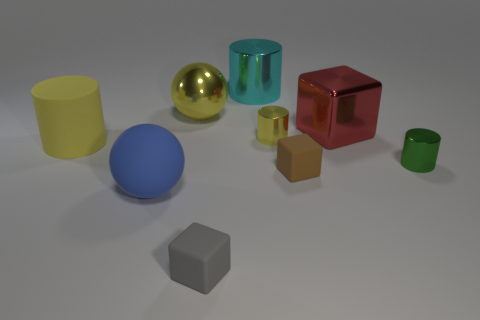What is the material of the large object that is the same color as the shiny ball?
Give a very brief answer. Rubber. Is the color of the rubber ball the same as the metallic sphere?
Keep it short and to the point. No. Is the color of the tiny shiny cylinder right of the small yellow object the same as the cylinder that is behind the red thing?
Offer a terse response. No. There is a block that is behind the small matte block behind the gray rubber block that is on the right side of the big rubber cylinder; how big is it?
Your answer should be very brief. Large. There is another rubber object that is the same shape as the gray rubber thing; what color is it?
Provide a succinct answer. Brown. Is the number of large balls that are to the right of the brown rubber thing greater than the number of tiny green metallic cylinders?
Your response must be concise. No. Do the small gray object and the large yellow object that is in front of the big yellow metallic object have the same shape?
Provide a succinct answer. No. Are there any other things that have the same size as the blue thing?
Provide a succinct answer. Yes. The yellow rubber object that is the same shape as the green object is what size?
Make the answer very short. Large. Are there more blue rubber spheres than small cylinders?
Your answer should be compact. No. 